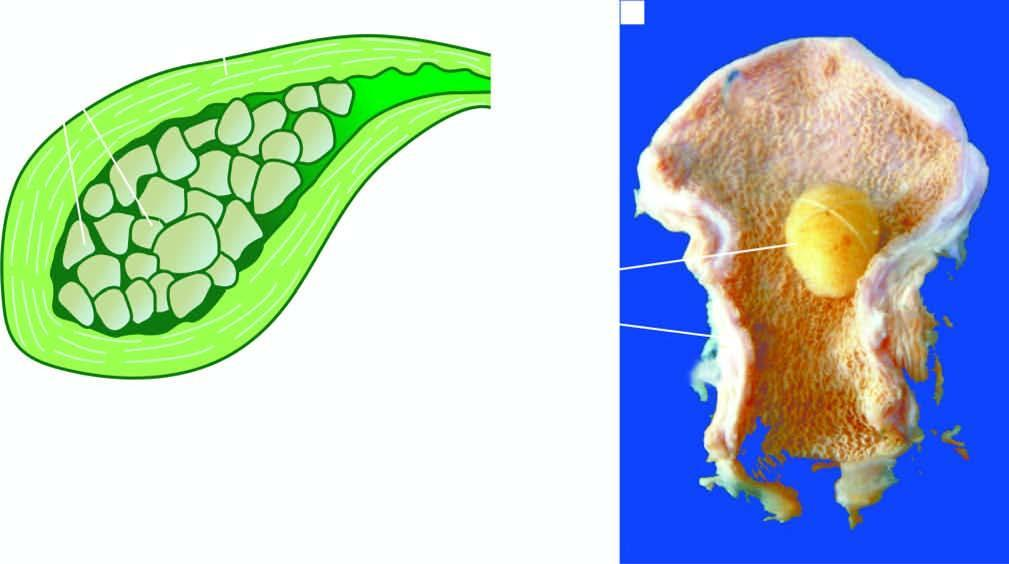s the lumen packed with well-fitting, multiple, multi-faceted, mixed gallstones?
Answer the question using a single word or phrase. Yes 